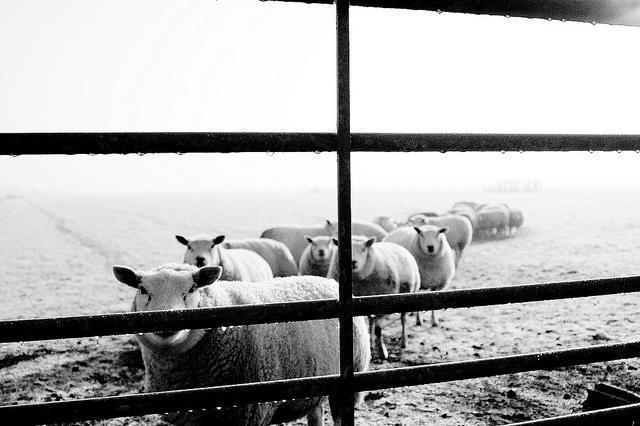How many sheep are in the picture?
Give a very brief answer. 4. How many remote controls are on the table?
Give a very brief answer. 0. 